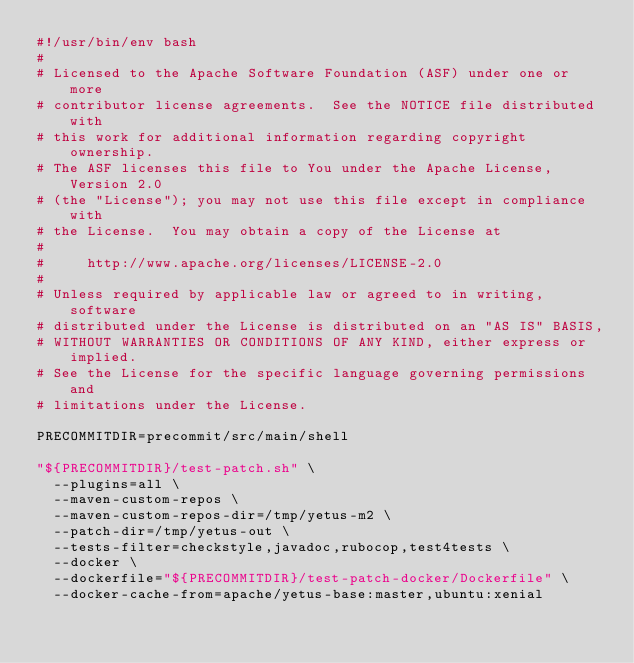<code> <loc_0><loc_0><loc_500><loc_500><_Bash_>#!/usr/bin/env bash
#
# Licensed to the Apache Software Foundation (ASF) under one or more
# contributor license agreements.  See the NOTICE file distributed with
# this work for additional information regarding copyright ownership.
# The ASF licenses this file to You under the Apache License, Version 2.0
# (the "License"); you may not use this file except in compliance with
# the License.  You may obtain a copy of the License at
#
#     http://www.apache.org/licenses/LICENSE-2.0
#
# Unless required by applicable law or agreed to in writing, software
# distributed under the License is distributed on an "AS IS" BASIS,
# WITHOUT WARRANTIES OR CONDITIONS OF ANY KIND, either express or implied.
# See the License for the specific language governing permissions and
# limitations under the License.

PRECOMMITDIR=precommit/src/main/shell

"${PRECOMMITDIR}/test-patch.sh" \
  --plugins=all \
  --maven-custom-repos \
  --maven-custom-repos-dir=/tmp/yetus-m2 \
  --patch-dir=/tmp/yetus-out \
  --tests-filter=checkstyle,javadoc,rubocop,test4tests \
  --docker \
  --dockerfile="${PRECOMMITDIR}/test-patch-docker/Dockerfile" \
  --docker-cache-from=apache/yetus-base:master,ubuntu:xenial
</code> 